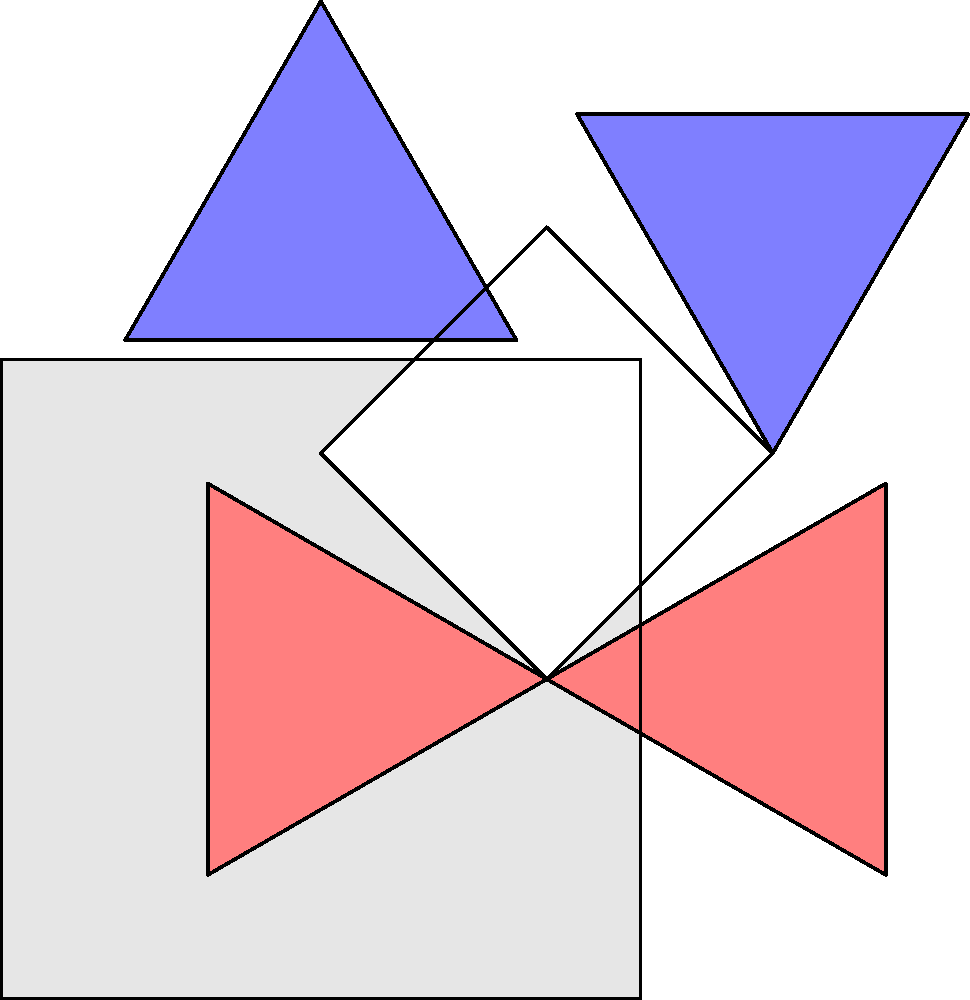Consider the decorative mosaic pattern shown above, which was found in an ancient architectural piece. This pattern exhibits symmetries that form a dihedral group. Determine the order of the dihedral group for this mosaic pattern and list all the symmetry operations (rotations and reflections) that preserve the pattern. To answer this question, we need to analyze the symmetries of the given mosaic pattern:

1. Rotational symmetries:
   - Identity (0° rotation)
   - 90° clockwise rotation
   - 180° rotation
   - 270° clockwise rotation (or 90° counterclockwise)

2. Reflection symmetries:
   - Reflection across the vertical axis
   - Reflection across the horizontal axis
   - Reflection across the diagonal from top-left to bottom-right
   - Reflection across the diagonal from top-right to bottom-left

The total number of symmetry operations is 8, which means this pattern has the symmetries of the dihedral group $D_4$.

The order of a dihedral group $D_n$ is given by the formula $|D_n| = 2n$, where $n$ is the number of rotational symmetries. In this case, $n = 4$, so the order of the group is $|D_4| = 2 \cdot 4 = 8$.

The complete list of symmetry operations for $D_4$ is:
1. Identity ($e$)
2. 90° clockwise rotation ($r$)
3. 180° rotation ($r^2$)
4. 270° clockwise rotation ($r^3$)
5. Reflection across the vertical axis ($s$)
6. Reflection across the horizontal axis ($sr^2$)
7. Reflection across the diagonal from top-left to bottom-right ($sr^3$)
8. Reflection across the diagonal from top-right to bottom-left ($sr$)

These symmetry operations form the dihedral group $D_4$, which preserves the structure of the mosaic pattern.
Answer: Order: 8; Symmetries: $e$, $r$, $r^2$, $r^3$, $s$, $sr^2$, $sr^3$, $sr$ 